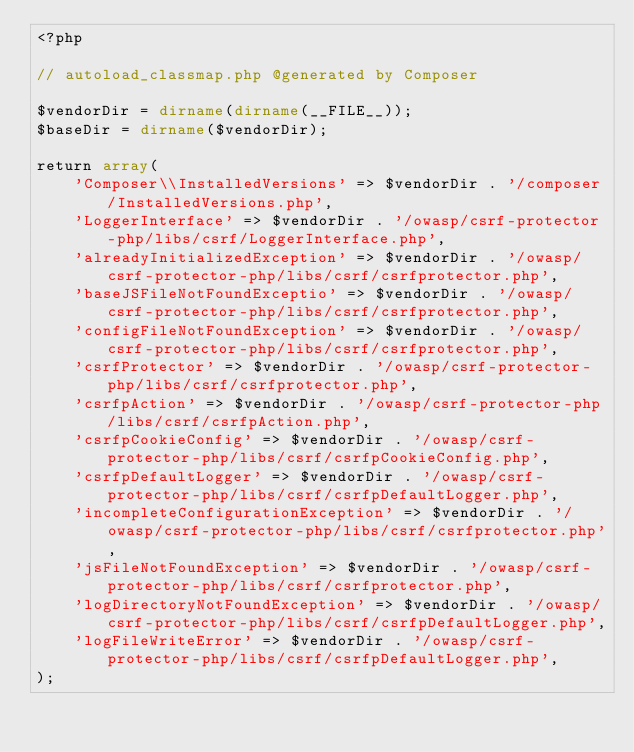<code> <loc_0><loc_0><loc_500><loc_500><_PHP_><?php

// autoload_classmap.php @generated by Composer

$vendorDir = dirname(dirname(__FILE__));
$baseDir = dirname($vendorDir);

return array(
    'Composer\\InstalledVersions' => $vendorDir . '/composer/InstalledVersions.php',
    'LoggerInterface' => $vendorDir . '/owasp/csrf-protector-php/libs/csrf/LoggerInterface.php',
    'alreadyInitializedException' => $vendorDir . '/owasp/csrf-protector-php/libs/csrf/csrfprotector.php',
    'baseJSFileNotFoundExceptio' => $vendorDir . '/owasp/csrf-protector-php/libs/csrf/csrfprotector.php',
    'configFileNotFoundException' => $vendorDir . '/owasp/csrf-protector-php/libs/csrf/csrfprotector.php',
    'csrfProtector' => $vendorDir . '/owasp/csrf-protector-php/libs/csrf/csrfprotector.php',
    'csrfpAction' => $vendorDir . '/owasp/csrf-protector-php/libs/csrf/csrfpAction.php',
    'csrfpCookieConfig' => $vendorDir . '/owasp/csrf-protector-php/libs/csrf/csrfpCookieConfig.php',
    'csrfpDefaultLogger' => $vendorDir . '/owasp/csrf-protector-php/libs/csrf/csrfpDefaultLogger.php',
    'incompleteConfigurationException' => $vendorDir . '/owasp/csrf-protector-php/libs/csrf/csrfprotector.php',
    'jsFileNotFoundException' => $vendorDir . '/owasp/csrf-protector-php/libs/csrf/csrfprotector.php',
    'logDirectoryNotFoundException' => $vendorDir . '/owasp/csrf-protector-php/libs/csrf/csrfpDefaultLogger.php',
    'logFileWriteError' => $vendorDir . '/owasp/csrf-protector-php/libs/csrf/csrfpDefaultLogger.php',
);
</code> 